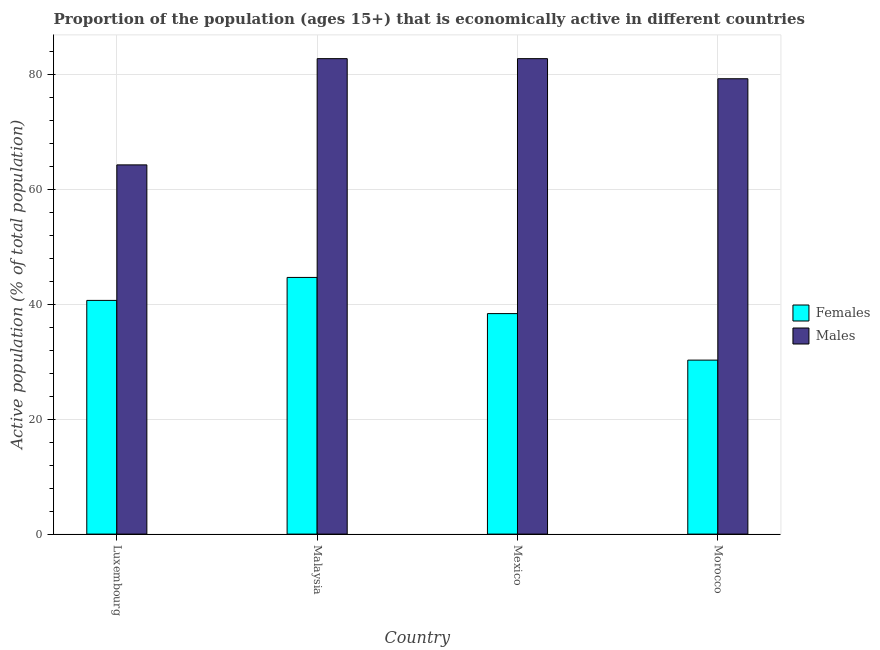Are the number of bars on each tick of the X-axis equal?
Your answer should be very brief. Yes. How many bars are there on the 4th tick from the left?
Keep it short and to the point. 2. What is the label of the 2nd group of bars from the left?
Offer a terse response. Malaysia. In how many cases, is the number of bars for a given country not equal to the number of legend labels?
Keep it short and to the point. 0. What is the percentage of economically active female population in Luxembourg?
Your answer should be very brief. 40.7. Across all countries, what is the maximum percentage of economically active female population?
Your response must be concise. 44.7. Across all countries, what is the minimum percentage of economically active female population?
Your response must be concise. 30.3. In which country was the percentage of economically active female population maximum?
Offer a very short reply. Malaysia. In which country was the percentage of economically active male population minimum?
Keep it short and to the point. Luxembourg. What is the total percentage of economically active male population in the graph?
Offer a very short reply. 309.2. What is the difference between the percentage of economically active male population in Mexico and that in Morocco?
Offer a very short reply. 3.5. What is the difference between the percentage of economically active female population in Mexico and the percentage of economically active male population in Malaysia?
Your response must be concise. -44.4. What is the average percentage of economically active female population per country?
Provide a succinct answer. 38.53. What is the difference between the percentage of economically active female population and percentage of economically active male population in Luxembourg?
Provide a short and direct response. -23.6. What is the ratio of the percentage of economically active male population in Luxembourg to that in Malaysia?
Make the answer very short. 0.78. Is the percentage of economically active male population in Luxembourg less than that in Morocco?
Your answer should be very brief. Yes. What is the difference between the highest and the lowest percentage of economically active male population?
Ensure brevity in your answer.  18.5. Is the sum of the percentage of economically active female population in Luxembourg and Morocco greater than the maximum percentage of economically active male population across all countries?
Offer a terse response. No. What does the 2nd bar from the left in Morocco represents?
Keep it short and to the point. Males. What does the 2nd bar from the right in Malaysia represents?
Your answer should be very brief. Females. How many countries are there in the graph?
Provide a succinct answer. 4. Are the values on the major ticks of Y-axis written in scientific E-notation?
Your answer should be very brief. No. Where does the legend appear in the graph?
Provide a short and direct response. Center right. How many legend labels are there?
Provide a short and direct response. 2. What is the title of the graph?
Provide a short and direct response. Proportion of the population (ages 15+) that is economically active in different countries. What is the label or title of the Y-axis?
Ensure brevity in your answer.  Active population (% of total population). What is the Active population (% of total population) of Females in Luxembourg?
Your answer should be very brief. 40.7. What is the Active population (% of total population) in Males in Luxembourg?
Keep it short and to the point. 64.3. What is the Active population (% of total population) of Females in Malaysia?
Give a very brief answer. 44.7. What is the Active population (% of total population) in Males in Malaysia?
Your response must be concise. 82.8. What is the Active population (% of total population) in Females in Mexico?
Ensure brevity in your answer.  38.4. What is the Active population (% of total population) of Males in Mexico?
Your answer should be very brief. 82.8. What is the Active population (% of total population) in Females in Morocco?
Make the answer very short. 30.3. What is the Active population (% of total population) of Males in Morocco?
Your answer should be very brief. 79.3. Across all countries, what is the maximum Active population (% of total population) of Females?
Provide a succinct answer. 44.7. Across all countries, what is the maximum Active population (% of total population) in Males?
Offer a terse response. 82.8. Across all countries, what is the minimum Active population (% of total population) of Females?
Offer a very short reply. 30.3. Across all countries, what is the minimum Active population (% of total population) of Males?
Offer a terse response. 64.3. What is the total Active population (% of total population) in Females in the graph?
Your answer should be very brief. 154.1. What is the total Active population (% of total population) of Males in the graph?
Keep it short and to the point. 309.2. What is the difference between the Active population (% of total population) in Males in Luxembourg and that in Malaysia?
Your response must be concise. -18.5. What is the difference between the Active population (% of total population) in Females in Luxembourg and that in Mexico?
Keep it short and to the point. 2.3. What is the difference between the Active population (% of total population) in Males in Luxembourg and that in Mexico?
Offer a terse response. -18.5. What is the difference between the Active population (% of total population) in Females in Luxembourg and that in Morocco?
Give a very brief answer. 10.4. What is the difference between the Active population (% of total population) of Males in Luxembourg and that in Morocco?
Your response must be concise. -15. What is the difference between the Active population (% of total population) in Females in Malaysia and that in Mexico?
Provide a succinct answer. 6.3. What is the difference between the Active population (% of total population) of Females in Mexico and that in Morocco?
Provide a succinct answer. 8.1. What is the difference between the Active population (% of total population) in Females in Luxembourg and the Active population (% of total population) in Males in Malaysia?
Offer a terse response. -42.1. What is the difference between the Active population (% of total population) in Females in Luxembourg and the Active population (% of total population) in Males in Mexico?
Provide a short and direct response. -42.1. What is the difference between the Active population (% of total population) in Females in Luxembourg and the Active population (% of total population) in Males in Morocco?
Your answer should be very brief. -38.6. What is the difference between the Active population (% of total population) in Females in Malaysia and the Active population (% of total population) in Males in Mexico?
Give a very brief answer. -38.1. What is the difference between the Active population (% of total population) of Females in Malaysia and the Active population (% of total population) of Males in Morocco?
Your answer should be compact. -34.6. What is the difference between the Active population (% of total population) of Females in Mexico and the Active population (% of total population) of Males in Morocco?
Offer a very short reply. -40.9. What is the average Active population (% of total population) in Females per country?
Give a very brief answer. 38.52. What is the average Active population (% of total population) in Males per country?
Your answer should be very brief. 77.3. What is the difference between the Active population (% of total population) in Females and Active population (% of total population) in Males in Luxembourg?
Give a very brief answer. -23.6. What is the difference between the Active population (% of total population) of Females and Active population (% of total population) of Males in Malaysia?
Your answer should be very brief. -38.1. What is the difference between the Active population (% of total population) in Females and Active population (% of total population) in Males in Mexico?
Provide a short and direct response. -44.4. What is the difference between the Active population (% of total population) of Females and Active population (% of total population) of Males in Morocco?
Ensure brevity in your answer.  -49. What is the ratio of the Active population (% of total population) of Females in Luxembourg to that in Malaysia?
Offer a terse response. 0.91. What is the ratio of the Active population (% of total population) in Males in Luxembourg to that in Malaysia?
Keep it short and to the point. 0.78. What is the ratio of the Active population (% of total population) of Females in Luxembourg to that in Mexico?
Offer a terse response. 1.06. What is the ratio of the Active population (% of total population) in Males in Luxembourg to that in Mexico?
Your response must be concise. 0.78. What is the ratio of the Active population (% of total population) in Females in Luxembourg to that in Morocco?
Your response must be concise. 1.34. What is the ratio of the Active population (% of total population) of Males in Luxembourg to that in Morocco?
Your answer should be compact. 0.81. What is the ratio of the Active population (% of total population) in Females in Malaysia to that in Mexico?
Keep it short and to the point. 1.16. What is the ratio of the Active population (% of total population) of Males in Malaysia to that in Mexico?
Give a very brief answer. 1. What is the ratio of the Active population (% of total population) in Females in Malaysia to that in Morocco?
Provide a succinct answer. 1.48. What is the ratio of the Active population (% of total population) of Males in Malaysia to that in Morocco?
Your answer should be very brief. 1.04. What is the ratio of the Active population (% of total population) in Females in Mexico to that in Morocco?
Ensure brevity in your answer.  1.27. What is the ratio of the Active population (% of total population) in Males in Mexico to that in Morocco?
Your answer should be compact. 1.04. What is the difference between the highest and the second highest Active population (% of total population) in Males?
Give a very brief answer. 0. What is the difference between the highest and the lowest Active population (% of total population) in Males?
Give a very brief answer. 18.5. 